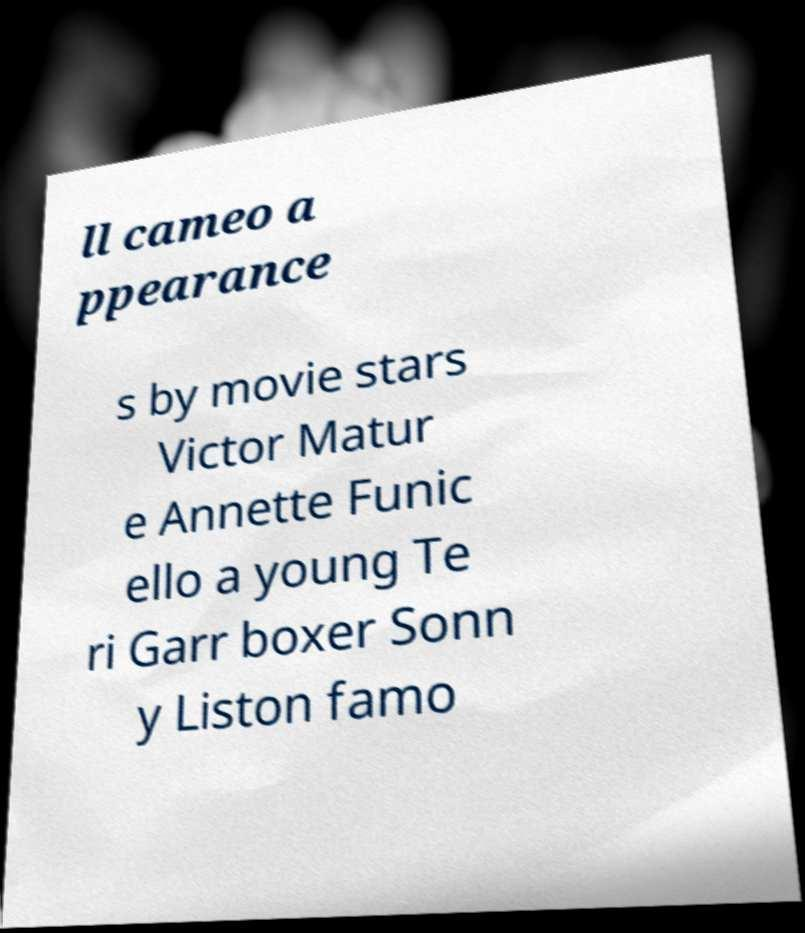Could you extract and type out the text from this image? ll cameo a ppearance s by movie stars Victor Matur e Annette Funic ello a young Te ri Garr boxer Sonn y Liston famo 